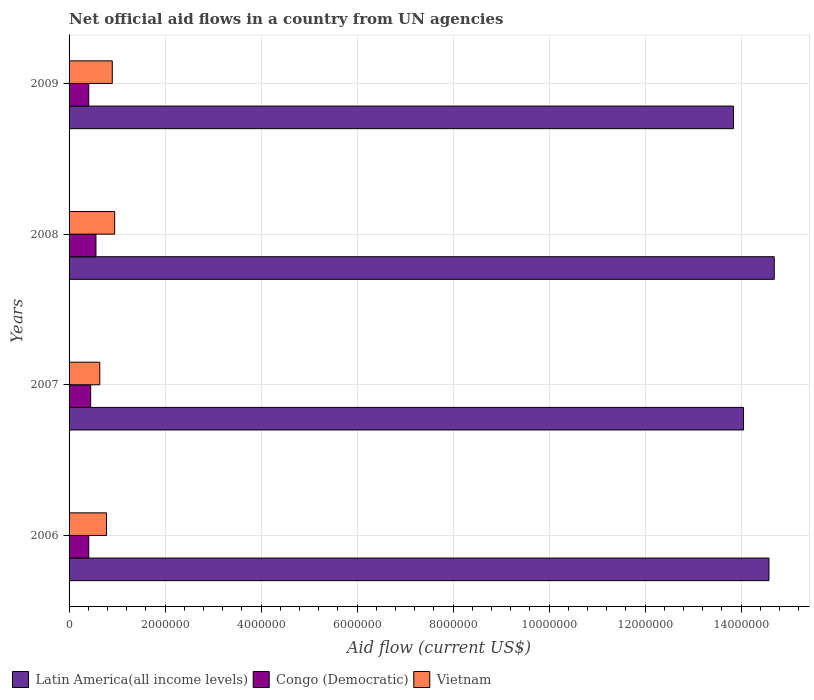How many groups of bars are there?
Your response must be concise. 4. Are the number of bars per tick equal to the number of legend labels?
Provide a succinct answer. Yes. How many bars are there on the 4th tick from the bottom?
Your answer should be very brief. 3. What is the label of the 3rd group of bars from the top?
Give a very brief answer. 2007. In how many cases, is the number of bars for a given year not equal to the number of legend labels?
Your answer should be very brief. 0. What is the net official aid flow in Congo (Democratic) in 2009?
Your answer should be very brief. 4.10e+05. Across all years, what is the maximum net official aid flow in Latin America(all income levels)?
Give a very brief answer. 1.47e+07. Across all years, what is the minimum net official aid flow in Congo (Democratic)?
Offer a very short reply. 4.10e+05. What is the total net official aid flow in Latin America(all income levels) in the graph?
Provide a succinct answer. 5.72e+07. What is the difference between the net official aid flow in Vietnam in 2006 and that in 2007?
Offer a very short reply. 1.40e+05. What is the difference between the net official aid flow in Vietnam in 2006 and the net official aid flow in Congo (Democratic) in 2008?
Your answer should be very brief. 2.20e+05. What is the average net official aid flow in Latin America(all income levels) per year?
Keep it short and to the point. 1.43e+07. In the year 2007, what is the difference between the net official aid flow in Latin America(all income levels) and net official aid flow in Vietnam?
Give a very brief answer. 1.34e+07. What is the ratio of the net official aid flow in Vietnam in 2006 to that in 2009?
Keep it short and to the point. 0.87. Is the net official aid flow in Latin America(all income levels) in 2006 less than that in 2007?
Provide a short and direct response. No. Is the difference between the net official aid flow in Latin America(all income levels) in 2008 and 2009 greater than the difference between the net official aid flow in Vietnam in 2008 and 2009?
Ensure brevity in your answer.  Yes. What is the difference between the highest and the lowest net official aid flow in Latin America(all income levels)?
Keep it short and to the point. 8.50e+05. What does the 2nd bar from the top in 2009 represents?
Keep it short and to the point. Congo (Democratic). What does the 3rd bar from the bottom in 2006 represents?
Your answer should be very brief. Vietnam. Is it the case that in every year, the sum of the net official aid flow in Vietnam and net official aid flow in Congo (Democratic) is greater than the net official aid flow in Latin America(all income levels)?
Offer a terse response. No. What is the difference between two consecutive major ticks on the X-axis?
Ensure brevity in your answer.  2.00e+06. Are the values on the major ticks of X-axis written in scientific E-notation?
Ensure brevity in your answer.  No. Does the graph contain any zero values?
Keep it short and to the point. No. Does the graph contain grids?
Offer a terse response. Yes. How are the legend labels stacked?
Your response must be concise. Horizontal. What is the title of the graph?
Give a very brief answer. Net official aid flows in a country from UN agencies. What is the label or title of the X-axis?
Your answer should be very brief. Aid flow (current US$). What is the label or title of the Y-axis?
Ensure brevity in your answer.  Years. What is the Aid flow (current US$) in Latin America(all income levels) in 2006?
Provide a succinct answer. 1.46e+07. What is the Aid flow (current US$) in Vietnam in 2006?
Keep it short and to the point. 7.80e+05. What is the Aid flow (current US$) in Latin America(all income levels) in 2007?
Your answer should be very brief. 1.40e+07. What is the Aid flow (current US$) of Congo (Democratic) in 2007?
Offer a terse response. 4.50e+05. What is the Aid flow (current US$) of Vietnam in 2007?
Ensure brevity in your answer.  6.40e+05. What is the Aid flow (current US$) of Latin America(all income levels) in 2008?
Your answer should be compact. 1.47e+07. What is the Aid flow (current US$) in Congo (Democratic) in 2008?
Your answer should be very brief. 5.60e+05. What is the Aid flow (current US$) in Vietnam in 2008?
Offer a terse response. 9.50e+05. What is the Aid flow (current US$) of Latin America(all income levels) in 2009?
Ensure brevity in your answer.  1.38e+07. What is the Aid flow (current US$) in Vietnam in 2009?
Give a very brief answer. 9.00e+05. Across all years, what is the maximum Aid flow (current US$) in Latin America(all income levels)?
Your answer should be very brief. 1.47e+07. Across all years, what is the maximum Aid flow (current US$) of Congo (Democratic)?
Give a very brief answer. 5.60e+05. Across all years, what is the maximum Aid flow (current US$) of Vietnam?
Keep it short and to the point. 9.50e+05. Across all years, what is the minimum Aid flow (current US$) in Latin America(all income levels)?
Offer a very short reply. 1.38e+07. Across all years, what is the minimum Aid flow (current US$) in Vietnam?
Your answer should be compact. 6.40e+05. What is the total Aid flow (current US$) in Latin America(all income levels) in the graph?
Your response must be concise. 5.72e+07. What is the total Aid flow (current US$) in Congo (Democratic) in the graph?
Your answer should be compact. 1.83e+06. What is the total Aid flow (current US$) of Vietnam in the graph?
Ensure brevity in your answer.  3.27e+06. What is the difference between the Aid flow (current US$) in Latin America(all income levels) in 2006 and that in 2007?
Your answer should be very brief. 5.30e+05. What is the difference between the Aid flow (current US$) of Congo (Democratic) in 2006 and that in 2007?
Your response must be concise. -4.00e+04. What is the difference between the Aid flow (current US$) in Vietnam in 2006 and that in 2008?
Offer a terse response. -1.70e+05. What is the difference between the Aid flow (current US$) of Latin America(all income levels) in 2006 and that in 2009?
Give a very brief answer. 7.40e+05. What is the difference between the Aid flow (current US$) of Latin America(all income levels) in 2007 and that in 2008?
Offer a terse response. -6.40e+05. What is the difference between the Aid flow (current US$) in Vietnam in 2007 and that in 2008?
Make the answer very short. -3.10e+05. What is the difference between the Aid flow (current US$) in Latin America(all income levels) in 2007 and that in 2009?
Give a very brief answer. 2.10e+05. What is the difference between the Aid flow (current US$) in Latin America(all income levels) in 2008 and that in 2009?
Offer a very short reply. 8.50e+05. What is the difference between the Aid flow (current US$) of Congo (Democratic) in 2008 and that in 2009?
Keep it short and to the point. 1.50e+05. What is the difference between the Aid flow (current US$) of Vietnam in 2008 and that in 2009?
Provide a short and direct response. 5.00e+04. What is the difference between the Aid flow (current US$) in Latin America(all income levels) in 2006 and the Aid flow (current US$) in Congo (Democratic) in 2007?
Provide a short and direct response. 1.41e+07. What is the difference between the Aid flow (current US$) in Latin America(all income levels) in 2006 and the Aid flow (current US$) in Vietnam in 2007?
Keep it short and to the point. 1.39e+07. What is the difference between the Aid flow (current US$) in Congo (Democratic) in 2006 and the Aid flow (current US$) in Vietnam in 2007?
Give a very brief answer. -2.30e+05. What is the difference between the Aid flow (current US$) in Latin America(all income levels) in 2006 and the Aid flow (current US$) in Congo (Democratic) in 2008?
Make the answer very short. 1.40e+07. What is the difference between the Aid flow (current US$) in Latin America(all income levels) in 2006 and the Aid flow (current US$) in Vietnam in 2008?
Give a very brief answer. 1.36e+07. What is the difference between the Aid flow (current US$) in Congo (Democratic) in 2006 and the Aid flow (current US$) in Vietnam in 2008?
Ensure brevity in your answer.  -5.40e+05. What is the difference between the Aid flow (current US$) in Latin America(all income levels) in 2006 and the Aid flow (current US$) in Congo (Democratic) in 2009?
Offer a terse response. 1.42e+07. What is the difference between the Aid flow (current US$) of Latin America(all income levels) in 2006 and the Aid flow (current US$) of Vietnam in 2009?
Provide a succinct answer. 1.37e+07. What is the difference between the Aid flow (current US$) of Congo (Democratic) in 2006 and the Aid flow (current US$) of Vietnam in 2009?
Offer a terse response. -4.90e+05. What is the difference between the Aid flow (current US$) of Latin America(all income levels) in 2007 and the Aid flow (current US$) of Congo (Democratic) in 2008?
Offer a terse response. 1.35e+07. What is the difference between the Aid flow (current US$) in Latin America(all income levels) in 2007 and the Aid flow (current US$) in Vietnam in 2008?
Ensure brevity in your answer.  1.31e+07. What is the difference between the Aid flow (current US$) of Congo (Democratic) in 2007 and the Aid flow (current US$) of Vietnam in 2008?
Provide a succinct answer. -5.00e+05. What is the difference between the Aid flow (current US$) of Latin America(all income levels) in 2007 and the Aid flow (current US$) of Congo (Democratic) in 2009?
Make the answer very short. 1.36e+07. What is the difference between the Aid flow (current US$) in Latin America(all income levels) in 2007 and the Aid flow (current US$) in Vietnam in 2009?
Make the answer very short. 1.32e+07. What is the difference between the Aid flow (current US$) of Congo (Democratic) in 2007 and the Aid flow (current US$) of Vietnam in 2009?
Provide a short and direct response. -4.50e+05. What is the difference between the Aid flow (current US$) of Latin America(all income levels) in 2008 and the Aid flow (current US$) of Congo (Democratic) in 2009?
Ensure brevity in your answer.  1.43e+07. What is the difference between the Aid flow (current US$) of Latin America(all income levels) in 2008 and the Aid flow (current US$) of Vietnam in 2009?
Keep it short and to the point. 1.38e+07. What is the average Aid flow (current US$) of Latin America(all income levels) per year?
Offer a very short reply. 1.43e+07. What is the average Aid flow (current US$) in Congo (Democratic) per year?
Offer a terse response. 4.58e+05. What is the average Aid flow (current US$) of Vietnam per year?
Make the answer very short. 8.18e+05. In the year 2006, what is the difference between the Aid flow (current US$) in Latin America(all income levels) and Aid flow (current US$) in Congo (Democratic)?
Offer a terse response. 1.42e+07. In the year 2006, what is the difference between the Aid flow (current US$) in Latin America(all income levels) and Aid flow (current US$) in Vietnam?
Keep it short and to the point. 1.38e+07. In the year 2006, what is the difference between the Aid flow (current US$) in Congo (Democratic) and Aid flow (current US$) in Vietnam?
Ensure brevity in your answer.  -3.70e+05. In the year 2007, what is the difference between the Aid flow (current US$) in Latin America(all income levels) and Aid flow (current US$) in Congo (Democratic)?
Your answer should be very brief. 1.36e+07. In the year 2007, what is the difference between the Aid flow (current US$) of Latin America(all income levels) and Aid flow (current US$) of Vietnam?
Offer a very short reply. 1.34e+07. In the year 2008, what is the difference between the Aid flow (current US$) of Latin America(all income levels) and Aid flow (current US$) of Congo (Democratic)?
Ensure brevity in your answer.  1.41e+07. In the year 2008, what is the difference between the Aid flow (current US$) in Latin America(all income levels) and Aid flow (current US$) in Vietnam?
Make the answer very short. 1.37e+07. In the year 2008, what is the difference between the Aid flow (current US$) of Congo (Democratic) and Aid flow (current US$) of Vietnam?
Your response must be concise. -3.90e+05. In the year 2009, what is the difference between the Aid flow (current US$) of Latin America(all income levels) and Aid flow (current US$) of Congo (Democratic)?
Offer a very short reply. 1.34e+07. In the year 2009, what is the difference between the Aid flow (current US$) in Latin America(all income levels) and Aid flow (current US$) in Vietnam?
Make the answer very short. 1.29e+07. In the year 2009, what is the difference between the Aid flow (current US$) of Congo (Democratic) and Aid flow (current US$) of Vietnam?
Provide a short and direct response. -4.90e+05. What is the ratio of the Aid flow (current US$) in Latin America(all income levels) in 2006 to that in 2007?
Your response must be concise. 1.04. What is the ratio of the Aid flow (current US$) in Congo (Democratic) in 2006 to that in 2007?
Your response must be concise. 0.91. What is the ratio of the Aid flow (current US$) of Vietnam in 2006 to that in 2007?
Give a very brief answer. 1.22. What is the ratio of the Aid flow (current US$) of Latin America(all income levels) in 2006 to that in 2008?
Your answer should be very brief. 0.99. What is the ratio of the Aid flow (current US$) of Congo (Democratic) in 2006 to that in 2008?
Your answer should be very brief. 0.73. What is the ratio of the Aid flow (current US$) in Vietnam in 2006 to that in 2008?
Your answer should be very brief. 0.82. What is the ratio of the Aid flow (current US$) of Latin America(all income levels) in 2006 to that in 2009?
Your answer should be very brief. 1.05. What is the ratio of the Aid flow (current US$) of Vietnam in 2006 to that in 2009?
Offer a very short reply. 0.87. What is the ratio of the Aid flow (current US$) of Latin America(all income levels) in 2007 to that in 2008?
Your response must be concise. 0.96. What is the ratio of the Aid flow (current US$) of Congo (Democratic) in 2007 to that in 2008?
Offer a very short reply. 0.8. What is the ratio of the Aid flow (current US$) in Vietnam in 2007 to that in 2008?
Keep it short and to the point. 0.67. What is the ratio of the Aid flow (current US$) of Latin America(all income levels) in 2007 to that in 2009?
Give a very brief answer. 1.02. What is the ratio of the Aid flow (current US$) in Congo (Democratic) in 2007 to that in 2009?
Your answer should be compact. 1.1. What is the ratio of the Aid flow (current US$) in Vietnam in 2007 to that in 2009?
Your response must be concise. 0.71. What is the ratio of the Aid flow (current US$) in Latin America(all income levels) in 2008 to that in 2009?
Make the answer very short. 1.06. What is the ratio of the Aid flow (current US$) in Congo (Democratic) in 2008 to that in 2009?
Offer a very short reply. 1.37. What is the ratio of the Aid flow (current US$) in Vietnam in 2008 to that in 2009?
Keep it short and to the point. 1.06. What is the difference between the highest and the second highest Aid flow (current US$) of Congo (Democratic)?
Provide a short and direct response. 1.10e+05. What is the difference between the highest and the lowest Aid flow (current US$) of Latin America(all income levels)?
Your answer should be compact. 8.50e+05. What is the difference between the highest and the lowest Aid flow (current US$) of Congo (Democratic)?
Give a very brief answer. 1.50e+05. 